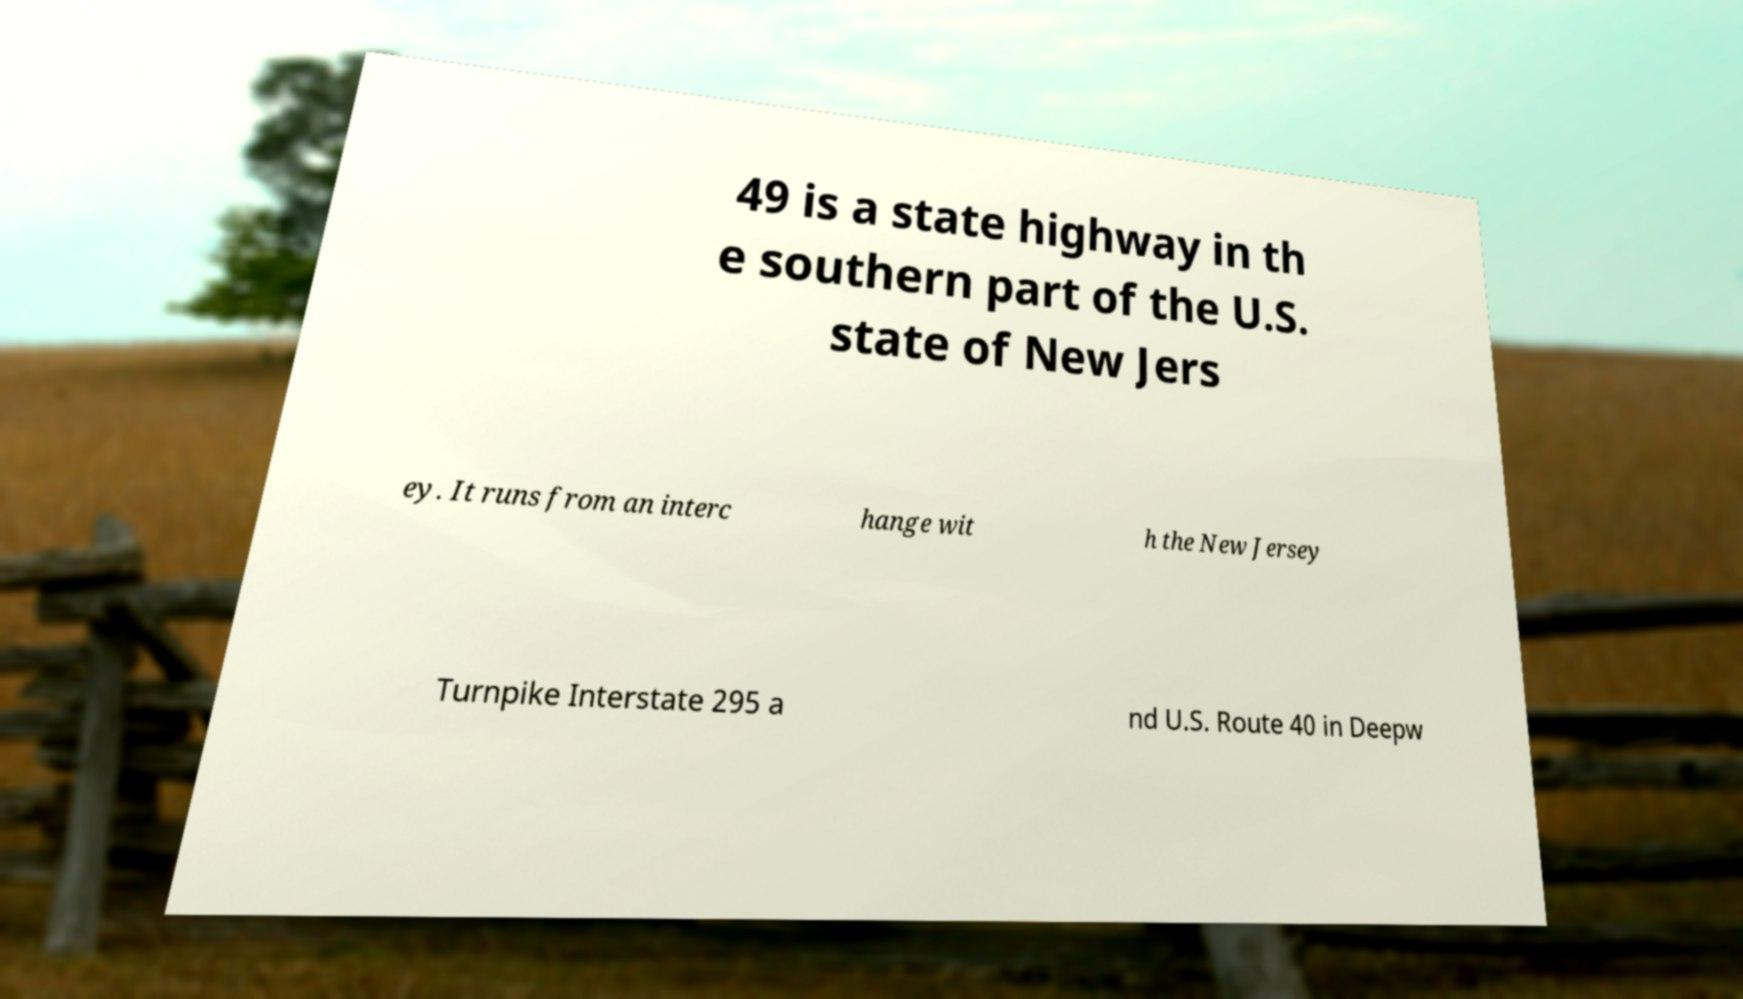What messages or text are displayed in this image? I need them in a readable, typed format. 49 is a state highway in th e southern part of the U.S. state of New Jers ey. It runs from an interc hange wit h the New Jersey Turnpike Interstate 295 a nd U.S. Route 40 in Deepw 